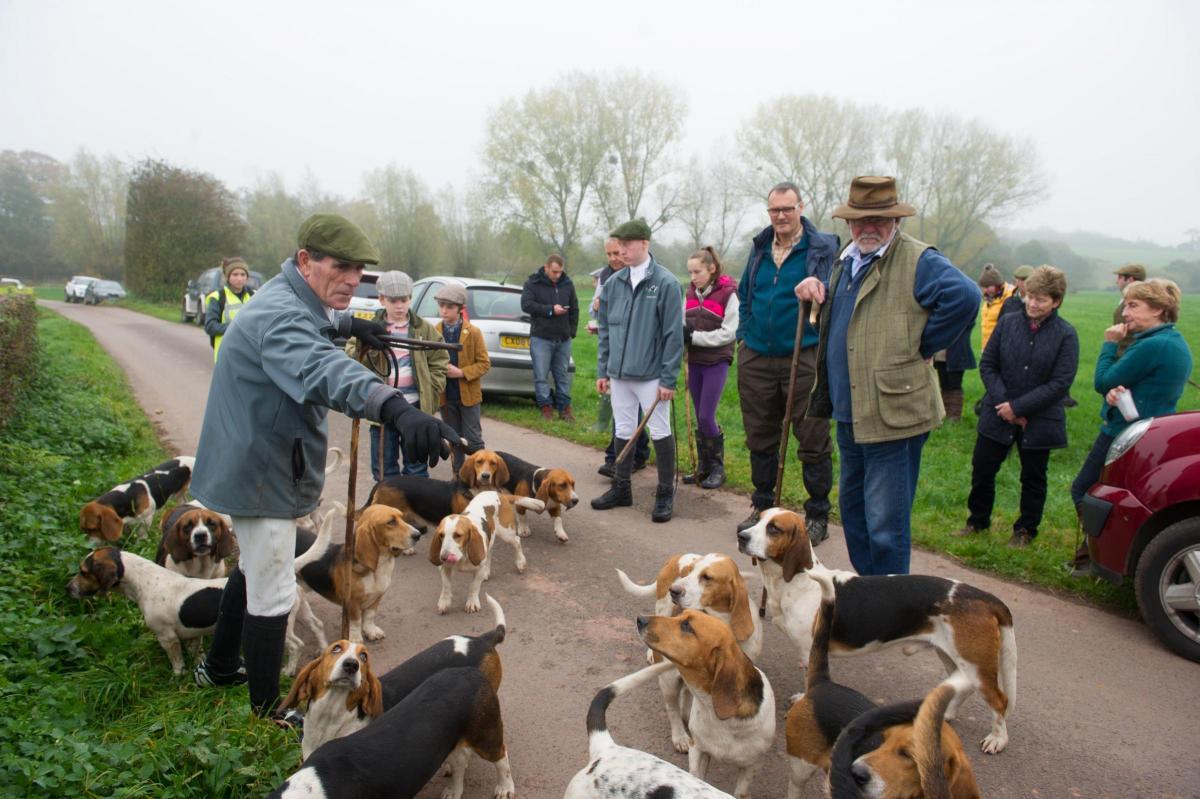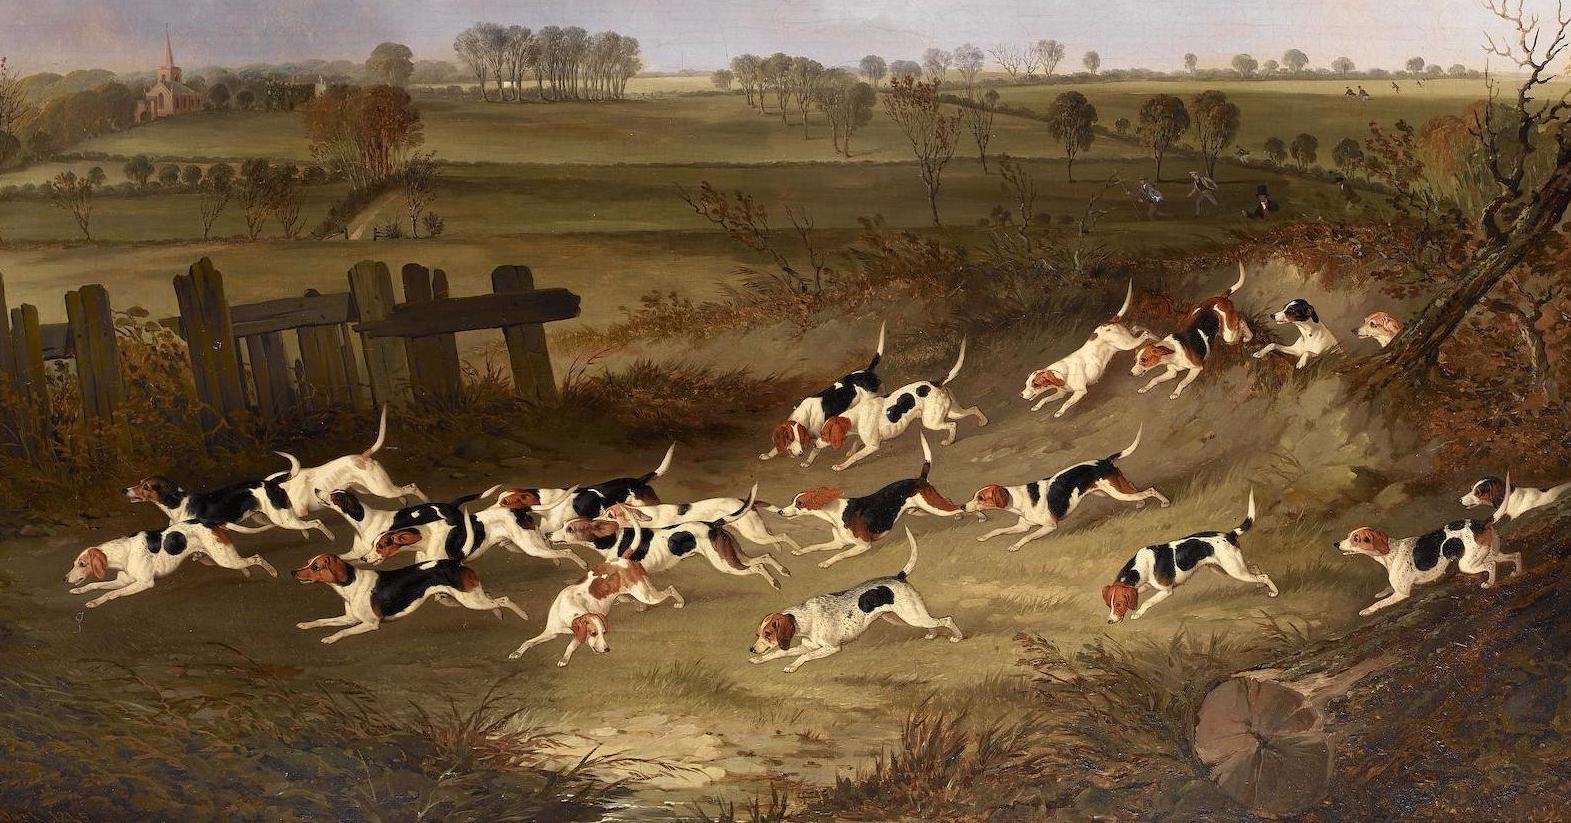The first image is the image on the left, the second image is the image on the right. Assess this claim about the two images: "A person in white pants and a dark green jacket is standing near hounds and holding a whip in one of the images.". Correct or not? Answer yes or no. No. 